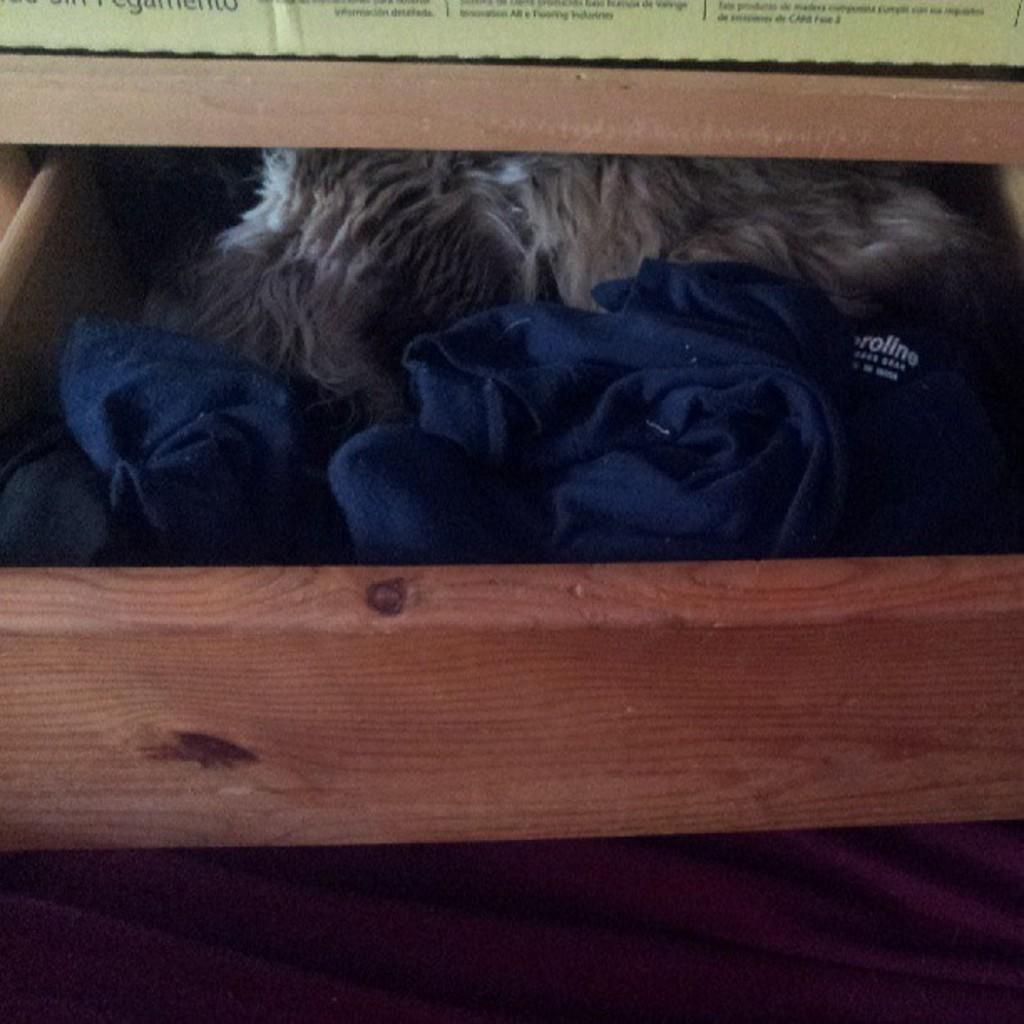Can you describe this image briefly? In this picture we can see a drawer, there are some clothes present in the draw, we can see some text at the top of the picture. 